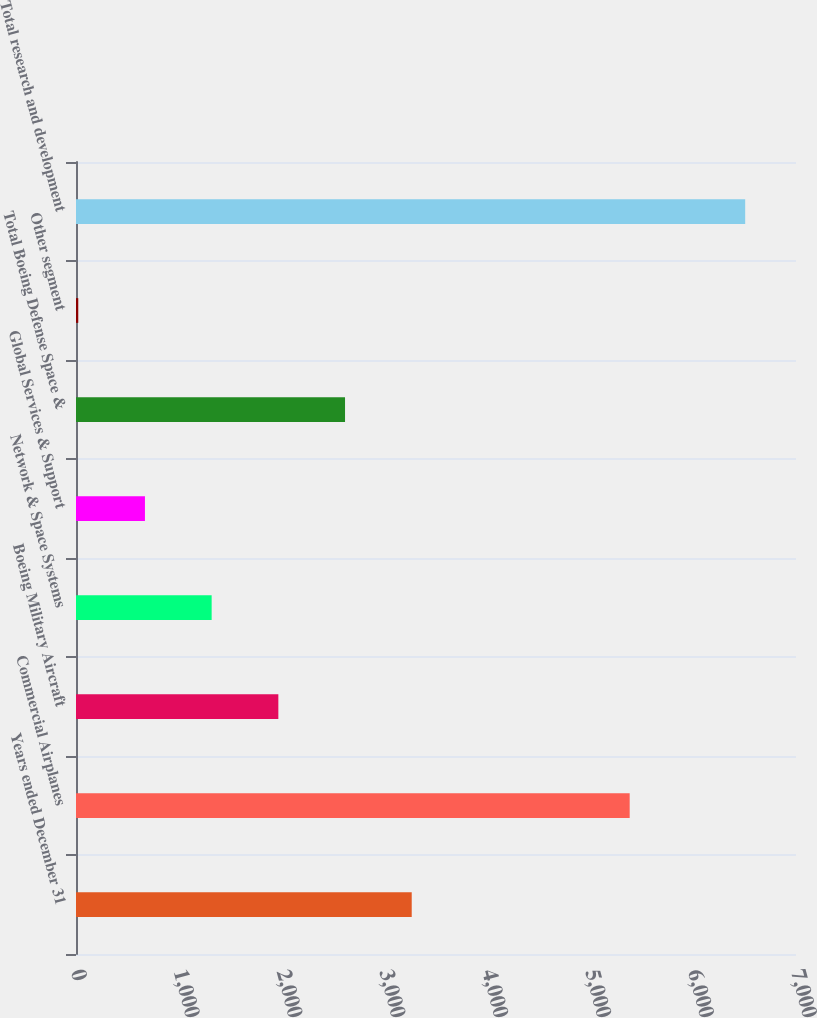<chart> <loc_0><loc_0><loc_500><loc_500><bar_chart><fcel>Years ended December 31<fcel>Commercial Airplanes<fcel>Boeing Military Aircraft<fcel>Network & Space Systems<fcel>Global Services & Support<fcel>Total Boeing Defense Space &<fcel>Other segment<fcel>Total research and development<nl><fcel>3264<fcel>5383<fcel>1967.2<fcel>1318.8<fcel>670.4<fcel>2615.6<fcel>22<fcel>6506<nl></chart> 